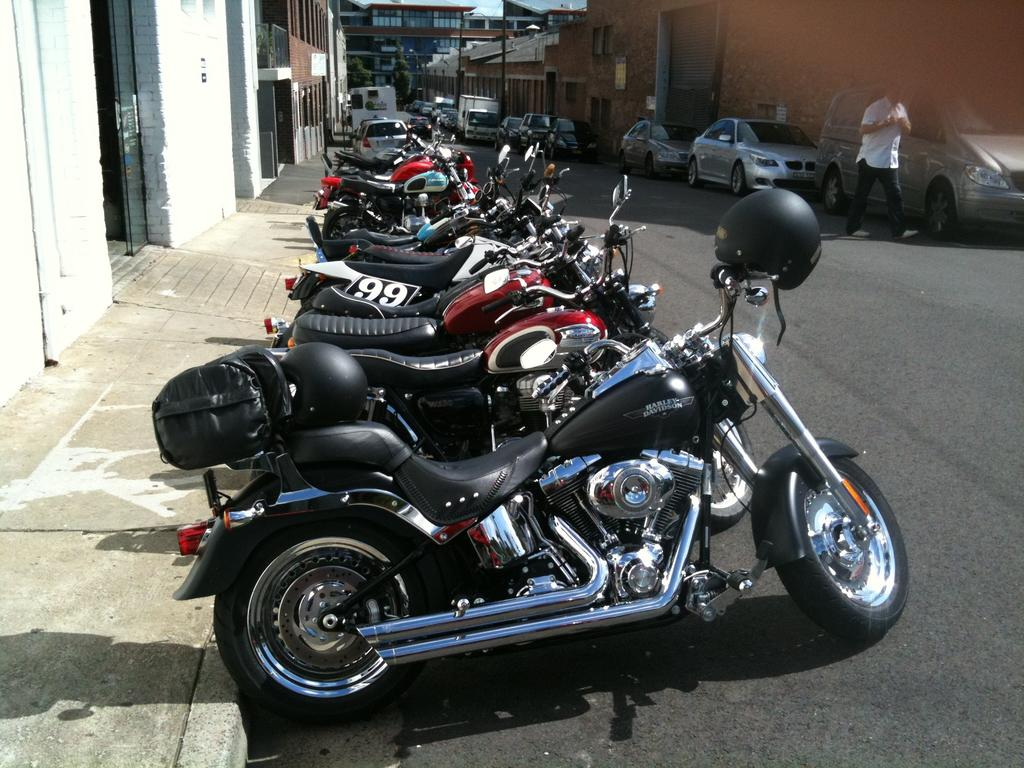What is the main feature of the image? There is a road in the image. What vehicles can be seen on the road? There are bikes and cars on the road. Is there anyone visible on the right side of the image? Yes, there is a man on the right side of the image. What can be seen in the background of the image? There are buildings in the background of the image. What type of vest is the screw wearing in the image? There is no vest or screw present in the image. 